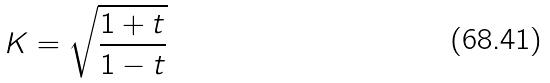<formula> <loc_0><loc_0><loc_500><loc_500>K = \sqrt { \frac { 1 + t } { 1 - t } }</formula> 